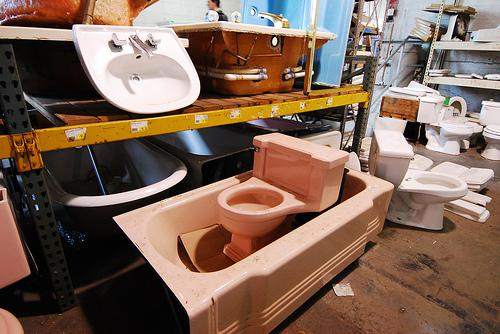Question: where was this taken?
Choices:
A. Doctor's office.
B. Fire station.
C. Warehouse.
D. College classroom.
Answer with the letter. Answer: C Question: what color is the bathtub with the toilet in it?
Choices:
A. White.
B. Pink.
C. Pale blue.
D. Mint green.
Answer with the letter. Answer: B Question: where are the sinks?
Choices:
A. On the shelf.
B. On the floor.
C. In the corner.
D. In the box.
Answer with the letter. Answer: A 